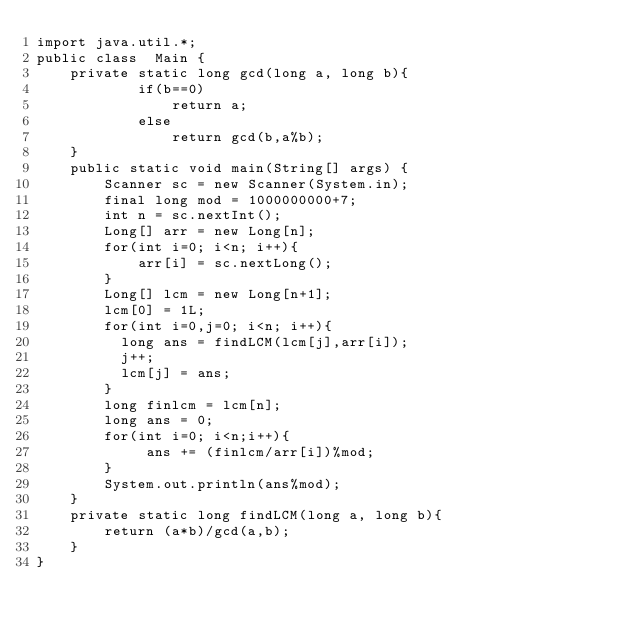<code> <loc_0><loc_0><loc_500><loc_500><_Java_>import java.util.*;
public class  Main {
    private static long gcd(long a, long b){
            if(b==0)
                return a;
            else
                return gcd(b,a%b);
    }
    public static void main(String[] args) {
        Scanner sc = new Scanner(System.in);
        final long mod = 1000000000+7;
        int n = sc.nextInt();
        Long[] arr = new Long[n];
        for(int i=0; i<n; i++){
            arr[i] = sc.nextLong();
        }
        Long[] lcm = new Long[n+1];
        lcm[0] = 1L;
        for(int i=0,j=0; i<n; i++){
          long ans = findLCM(lcm[j],arr[i]);
          j++;
          lcm[j] = ans;
        }
        long finlcm = lcm[n];
        long ans = 0;
        for(int i=0; i<n;i++){
             ans += (finlcm/arr[i])%mod;
        }
        System.out.println(ans%mod);
    }
    private static long findLCM(long a, long b){
        return (a*b)/gcd(a,b);
    }
}
</code> 